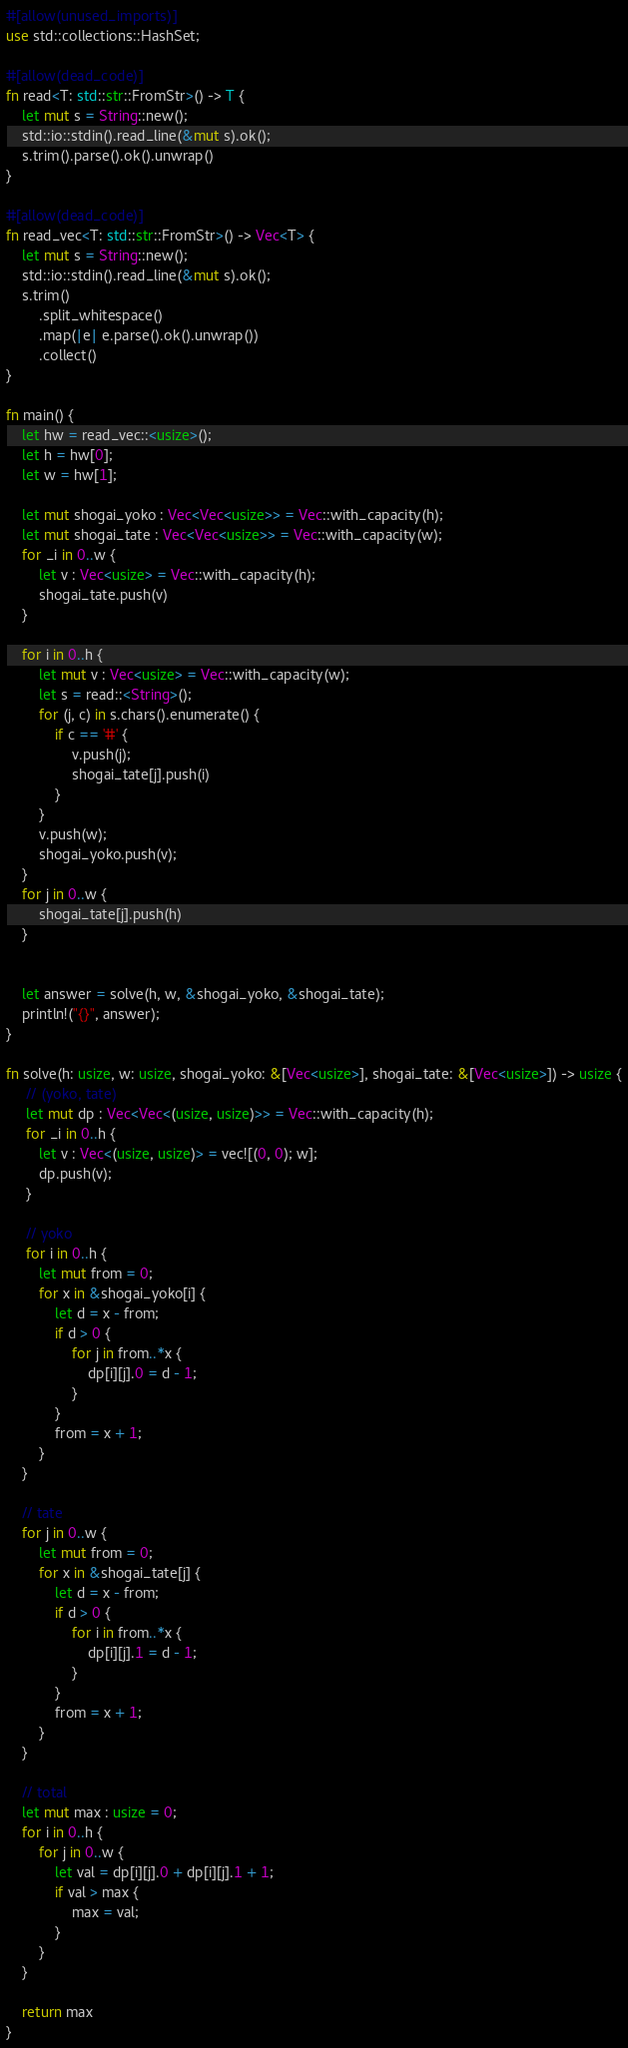Convert code to text. <code><loc_0><loc_0><loc_500><loc_500><_Rust_>#[allow(unused_imports)]
use std::collections::HashSet;

#[allow(dead_code)]
fn read<T: std::str::FromStr>() -> T {
    let mut s = String::new();
    std::io::stdin().read_line(&mut s).ok();
    s.trim().parse().ok().unwrap()
}

#[allow(dead_code)]
fn read_vec<T: std::str::FromStr>() -> Vec<T> {
    let mut s = String::new();
    std::io::stdin().read_line(&mut s).ok();
    s.trim()
        .split_whitespace()
        .map(|e| e.parse().ok().unwrap())
        .collect()
}

fn main() {
    let hw = read_vec::<usize>();
    let h = hw[0];
    let w = hw[1];

    let mut shogai_yoko : Vec<Vec<usize>> = Vec::with_capacity(h);
    let mut shogai_tate : Vec<Vec<usize>> = Vec::with_capacity(w);
    for _i in 0..w {
        let v : Vec<usize> = Vec::with_capacity(h);
        shogai_tate.push(v)
    }
    
    for i in 0..h {
        let mut v : Vec<usize> = Vec::with_capacity(w);
        let s = read::<String>();
        for (j, c) in s.chars().enumerate() {
            if c == '#' {
                v.push(j);
                shogai_tate[j].push(i)
            }
        }
        v.push(w);
        shogai_yoko.push(v);
    }
    for j in 0..w {
        shogai_tate[j].push(h)
    }


    let answer = solve(h, w, &shogai_yoko, &shogai_tate);
    println!("{}", answer);
}

fn solve(h: usize, w: usize, shogai_yoko: &[Vec<usize>], shogai_tate: &[Vec<usize>]) -> usize {
     // (yoko, tate)
     let mut dp : Vec<Vec<(usize, usize)>> = Vec::with_capacity(h);
     for _i in 0..h {
        let v : Vec<(usize, usize)> = vec![(0, 0); w];
        dp.push(v);
     }

     // yoko
     for i in 0..h {
        let mut from = 0;
        for x in &shogai_yoko[i] {
            let d = x - from;
            if d > 0 {
                for j in from..*x {
                    dp[i][j].0 = d - 1;
                }
            }
            from = x + 1;
        }
    }

    // tate
    for j in 0..w {
        let mut from = 0;
        for x in &shogai_tate[j] {
            let d = x - from;
            if d > 0 {
                for i in from..*x {
                    dp[i][j].1 = d - 1;
                }
            }
            from = x + 1;
        }
    }

    // total
    let mut max : usize = 0;
    for i in 0..h {
        for j in 0..w {
            let val = dp[i][j].0 + dp[i][j].1 + 1;
            if val > max {
                max = val;
            }
        }
    }

    return max
}
</code> 